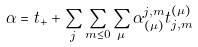Convert formula to latex. <formula><loc_0><loc_0><loc_500><loc_500>\alpha = t _ { + } + \sum _ { j } \sum _ { m \leq 0 } \sum _ { \mu } \alpha _ { ( \mu ) } ^ { j , m } t _ { j , m } ^ { ( \mu ) }</formula> 